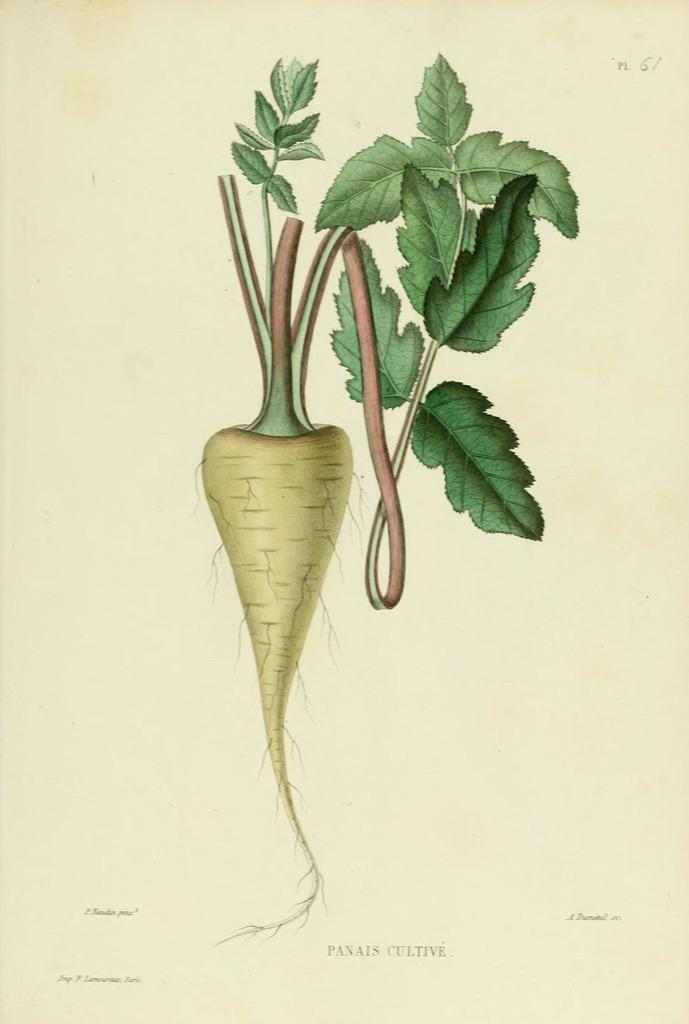What is the main subject of the image? There is a painting in the image. What does the painting depict? The painting depicts a vegetable plant. Where is the painting located in the image? The painting is in the center of the image. What type of glue is being used to attach the vegetable plant to the painting in the image? There is no glue or any indication of attaching the vegetable plant to the painting in the image; it is a two-dimensional representation. 